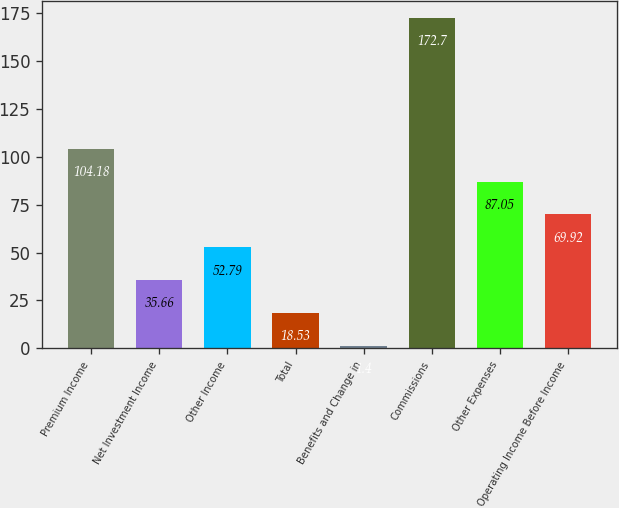Convert chart to OTSL. <chart><loc_0><loc_0><loc_500><loc_500><bar_chart><fcel>Premium Income<fcel>Net Investment Income<fcel>Other Income<fcel>Total<fcel>Benefits and Change in<fcel>Commissions<fcel>Other Expenses<fcel>Operating Income Before Income<nl><fcel>104.18<fcel>35.66<fcel>52.79<fcel>18.53<fcel>1.4<fcel>172.7<fcel>87.05<fcel>69.92<nl></chart> 